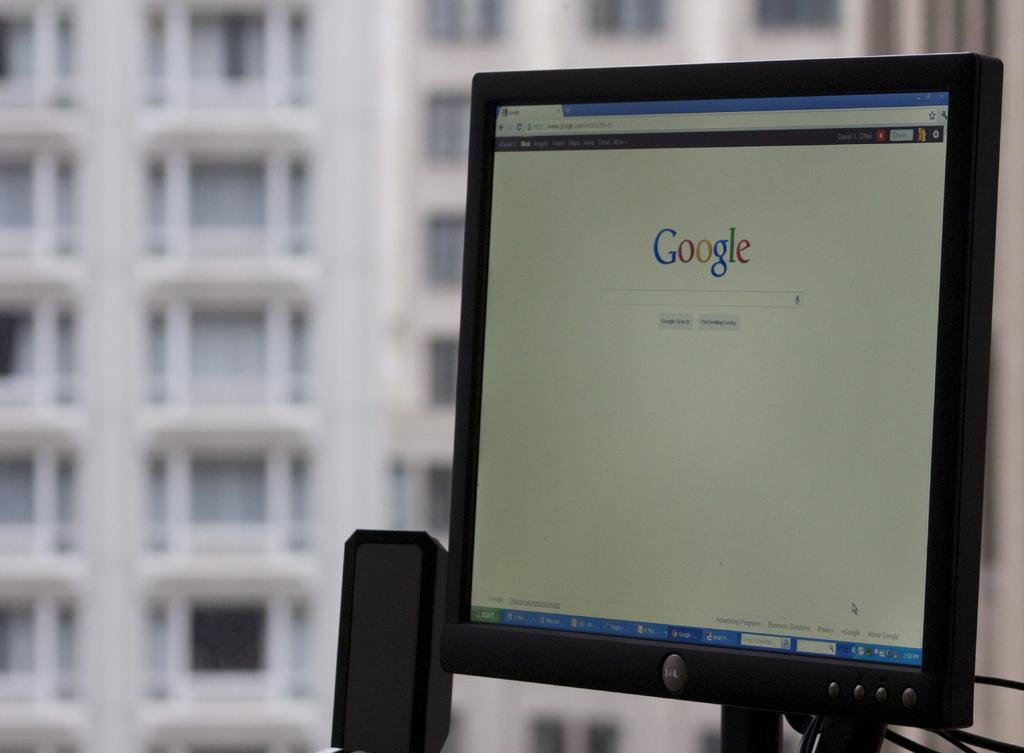What electronic device is present in the image? There is a monitor in the image. What other electronic device can be seen in the image? There is a speaker in the image. What can be seen in the background of the image? There is a building in the background of the image. What architectural feature is visible on the building in the background? Windows are visible on the building in the background. What type of pest can be seen crawling on the monitor in the image? There are no pests visible on the monitor in the image. What advice does the father give about using the speaker in the image? There is no father present in the image, and therefore no advice can be given about using the speaker. 